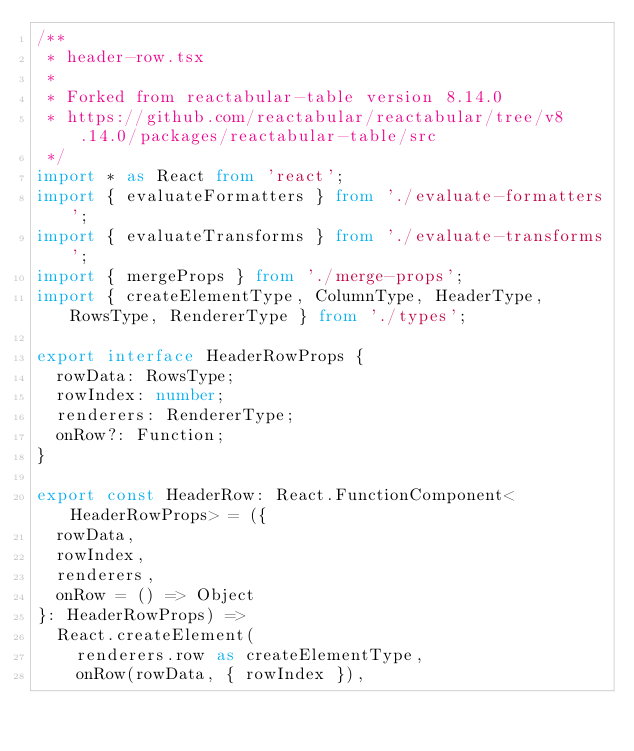<code> <loc_0><loc_0><loc_500><loc_500><_TypeScript_>/**
 * header-row.tsx
 *
 * Forked from reactabular-table version 8.14.0
 * https://github.com/reactabular/reactabular/tree/v8.14.0/packages/reactabular-table/src
 */
import * as React from 'react';
import { evaluateFormatters } from './evaluate-formatters';
import { evaluateTransforms } from './evaluate-transforms';
import { mergeProps } from './merge-props';
import { createElementType, ColumnType, HeaderType, RowsType, RendererType } from './types';

export interface HeaderRowProps {
  rowData: RowsType;
  rowIndex: number;
  renderers: RendererType;
  onRow?: Function;
}

export const HeaderRow: React.FunctionComponent<HeaderRowProps> = ({
  rowData,
  rowIndex,
  renderers,
  onRow = () => Object
}: HeaderRowProps) =>
  React.createElement(
    renderers.row as createElementType,
    onRow(rowData, { rowIndex }),</code> 